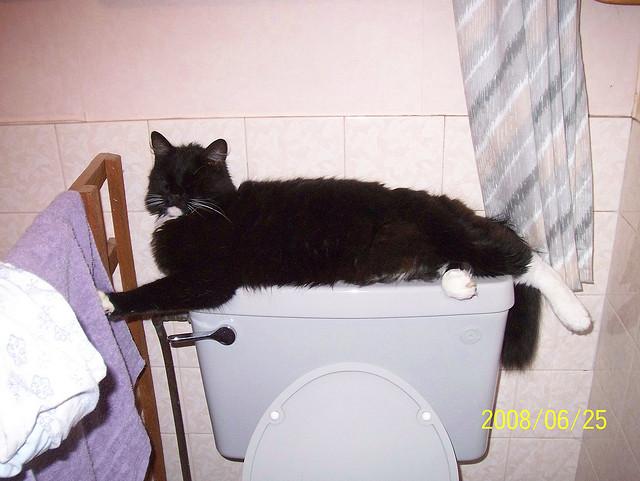What color are the cat's paws?
Give a very brief answer. White. Where is the cat?
Keep it brief. Toilet. What is the cat doing?
Be succinct. Sleeping. 